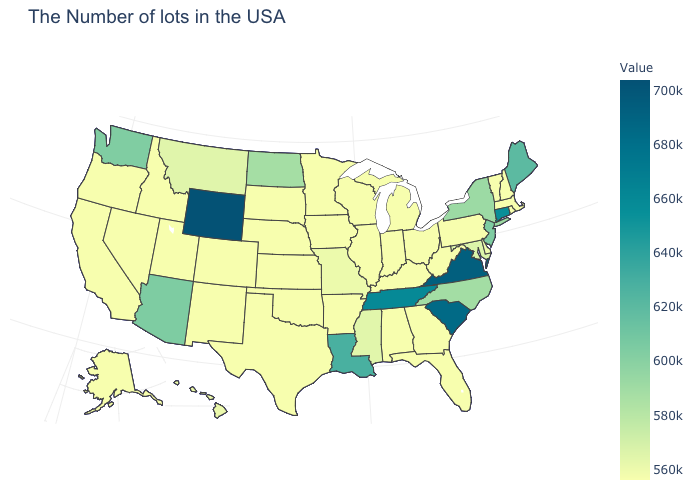Among the states that border Ohio , which have the lowest value?
Keep it brief. Pennsylvania, West Virginia, Michigan, Kentucky, Indiana. Does North Carolina have the highest value in the USA?
Keep it brief. No. 